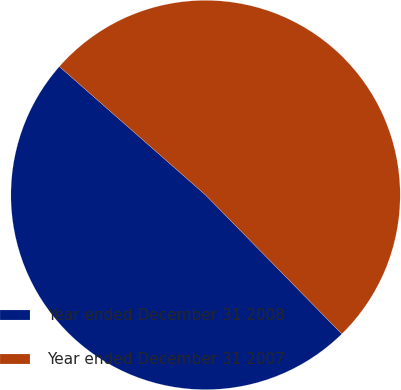Convert chart to OTSL. <chart><loc_0><loc_0><loc_500><loc_500><pie_chart><fcel>Year ended December 31 2008<fcel>Year ended December 31 2007<nl><fcel>48.82%<fcel>51.18%<nl></chart> 